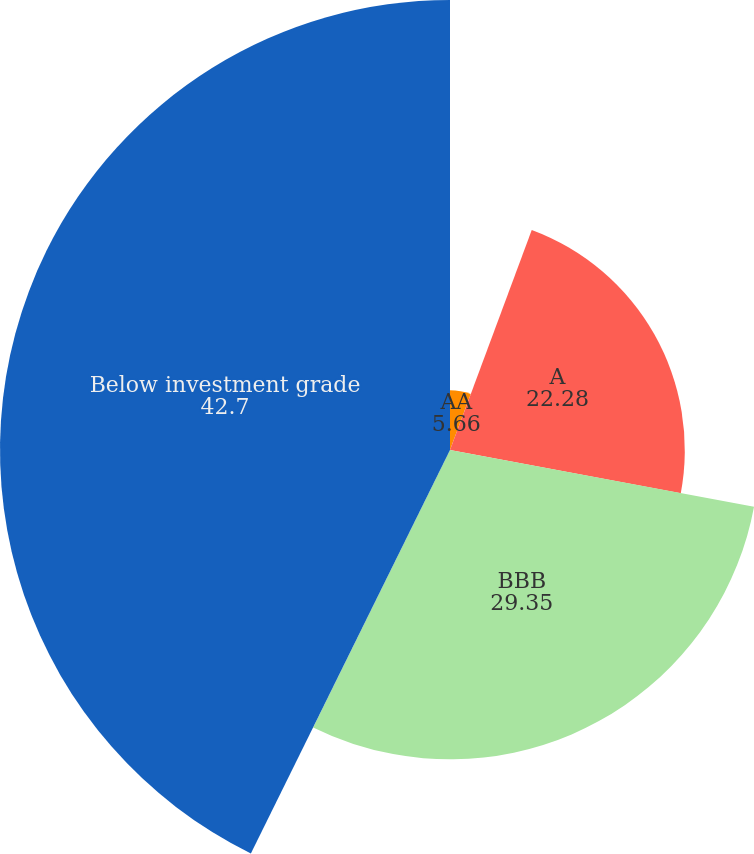Convert chart to OTSL. <chart><loc_0><loc_0><loc_500><loc_500><pie_chart><fcel>AA<fcel>A<fcel>BBB<fcel>Below investment grade<nl><fcel>5.66%<fcel>22.28%<fcel>29.35%<fcel>42.7%<nl></chart> 